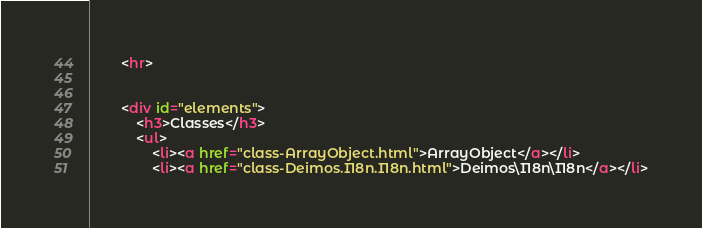Convert code to text. <code><loc_0><loc_0><loc_500><loc_500><_HTML_>
		<hr>


		<div id="elements">
			<h3>Classes</h3>
			<ul>
				<li><a href="class-ArrayObject.html">ArrayObject</a></li>
				<li><a href="class-Deimos.I18n.I18n.html">Deimos\I18n\I18n</a></li></code> 